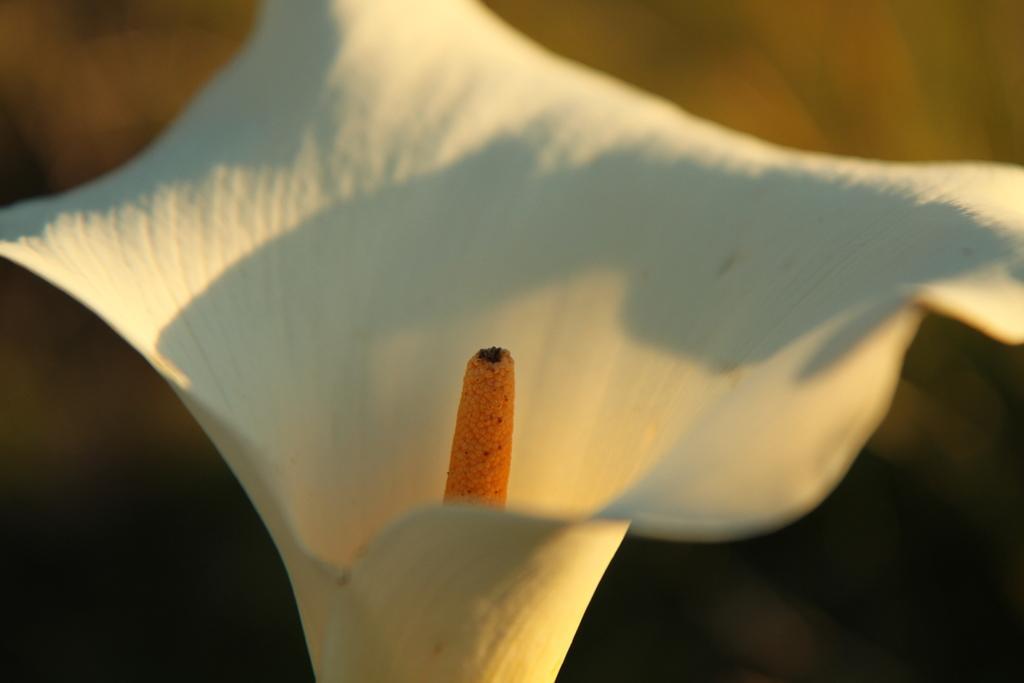Please provide a concise description of this image. In this image I can see a white and orange color flower. Background is in brown and black color. 